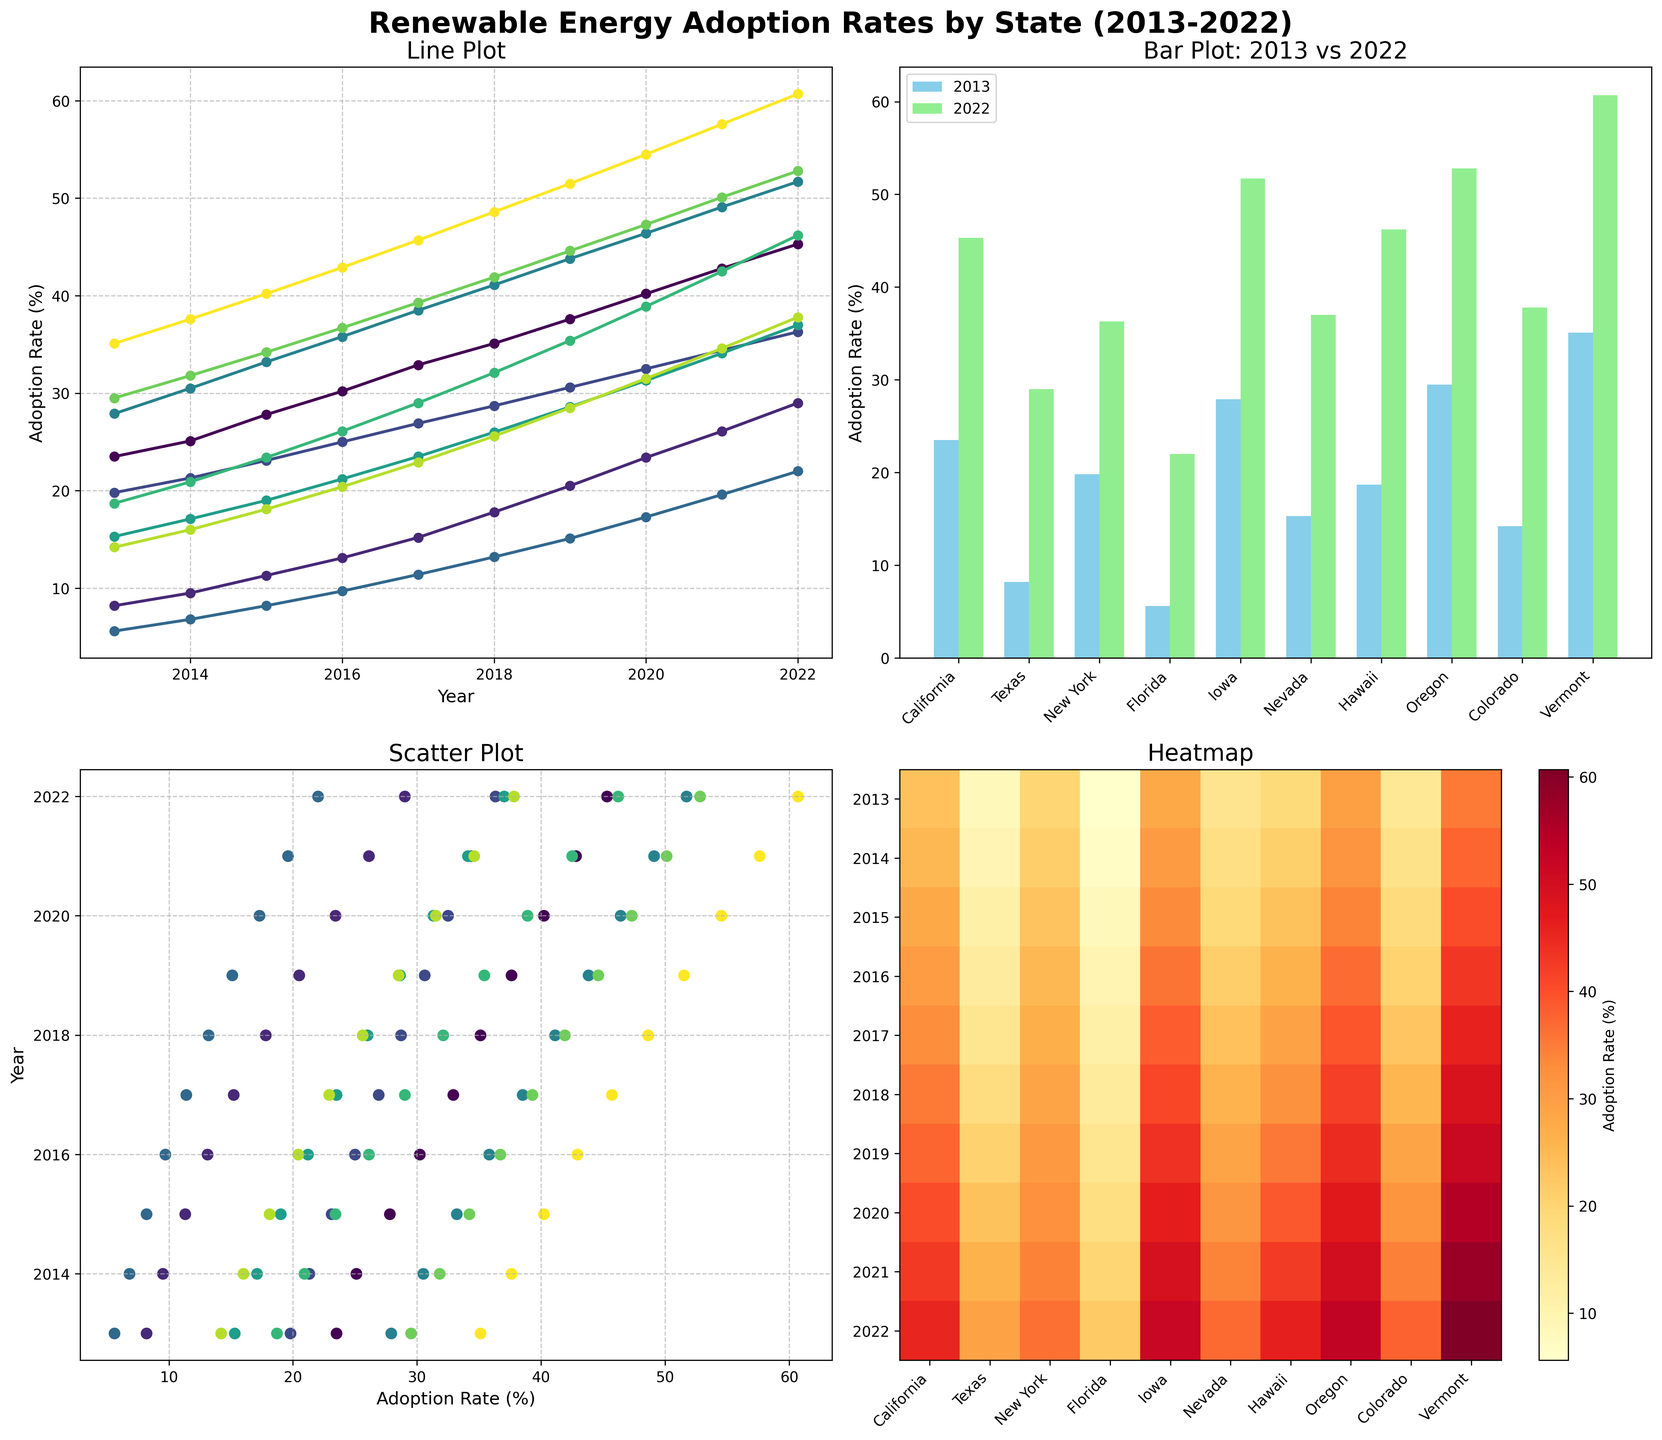What's the title of the entire figure? The title of the entire figure is written in bold at the top center of the plot.
Answer: Renewable Energy Adoption Rates by State (2013-2022) Which year has the highest adoption rate in Vermont in the line plot? By looking at the line plot, Vermont's adoption rate increases each year. The highest point will be at the end of the line corresponding to the year 2022.
Answer: 2022 What is the difference in adoption rates of renewable energy in Texas from 2013 to 2022 as shown in the bar plot? In the bar plot, locate the bars representing Texas for the years 2013 and 2022, and calculate the difference.
Answer: 20.8% Which state had the highest renewable energy adoption rate in 2022 according to the bar plot? By referring to the height of the bars representing the 2022 data in the bar plot, Vermont shows the tallest bar.
Answer: Vermont In the scatter plot, how is renewable energy adoption rate visually represented for each state? Each state's adoption rate over the years is represented by colored markers plotted according to their rates and years.
Answer: Colored markers Which state shows the steepest increase in renewable energy adoption rate over the decade in the line plot? In the line plot, the steepest increase can be identified by the line with the largest slope.
Answer: Vermont How does the heatmap represent the adoption rates for different years and states? The heatmap uses colors to represent different adoption rates, with the y-axis representing years and the x-axis representing states. Darker colors indicate higher adoption rates.
Answer: Colors show intensity Which state shows the largest absolute increase in renewable energy adoption between 2013 and 2022 in the bar plot? By comparing the bar heights representing 2013 and 2022 for each state in the bar plot, Vermont shows the largest increase.
Answer: Vermont What pattern do you observe in Oregon's adoption rates over the years in the line plot? The line plot for Oregon shows a consistent upward trend in adoption rates year over year.
Answer: Consistently increasing Compare the adoption rate trends of California and Nevada from 2013 to 2022 in the line plot. In the line plot, both states show increasing trends, but California starts and ends with higher adoption rates compared to Nevada. Nevada's rate of increase appears less steep than California's.
Answer: Both increasing, California higher 